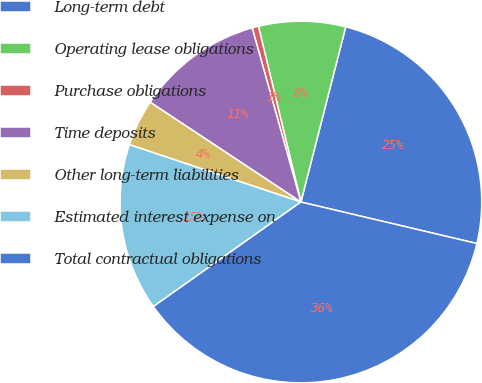Convert chart to OTSL. <chart><loc_0><loc_0><loc_500><loc_500><pie_chart><fcel>Long-term debt<fcel>Operating lease obligations<fcel>Purchase obligations<fcel>Time deposits<fcel>Other long-term liabilities<fcel>Estimated interest expense on<fcel>Total contractual obligations<nl><fcel>24.7%<fcel>7.76%<fcel>0.57%<fcel>11.35%<fcel>4.17%<fcel>14.95%<fcel>36.5%<nl></chart> 